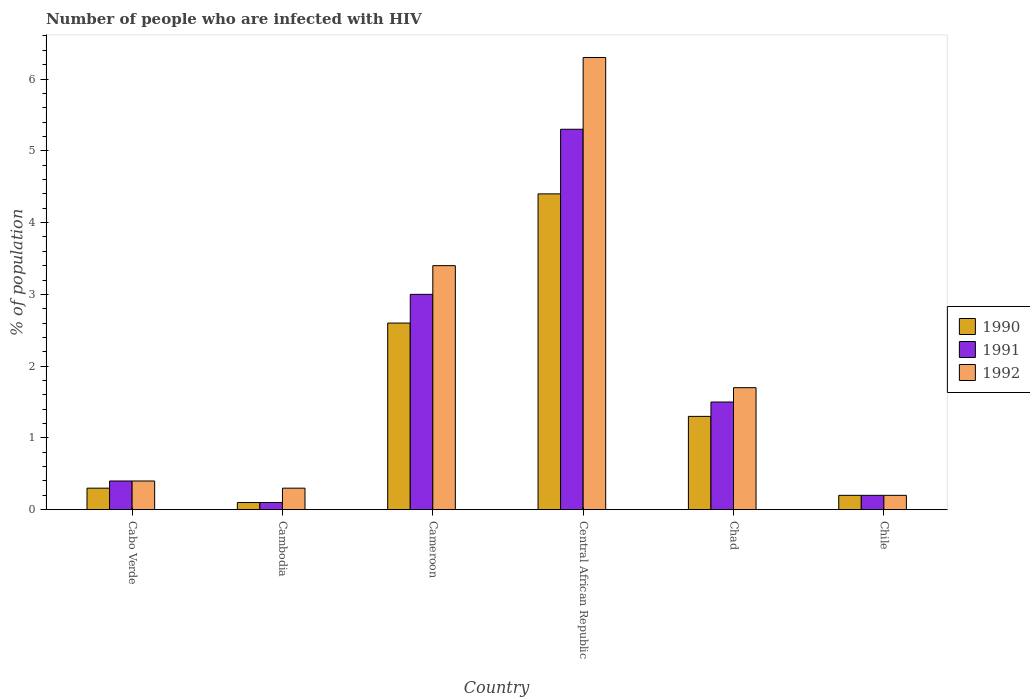How many groups of bars are there?
Provide a short and direct response. 6. Are the number of bars on each tick of the X-axis equal?
Your answer should be very brief. Yes. How many bars are there on the 3rd tick from the right?
Offer a very short reply. 3. What is the percentage of HIV infected population in in 1991 in Central African Republic?
Your response must be concise. 5.3. Across all countries, what is the maximum percentage of HIV infected population in in 1992?
Keep it short and to the point. 6.3. Across all countries, what is the minimum percentage of HIV infected population in in 1990?
Give a very brief answer. 0.1. In which country was the percentage of HIV infected population in in 1991 maximum?
Your response must be concise. Central African Republic. In which country was the percentage of HIV infected population in in 1990 minimum?
Give a very brief answer. Cambodia. What is the difference between the percentage of HIV infected population in in 1992 in Cameroon and that in Central African Republic?
Make the answer very short. -2.9. What is the difference between the percentage of HIV infected population in in 1991 in Cabo Verde and the percentage of HIV infected population in in 1992 in Chad?
Make the answer very short. -1.3. What is the difference between the percentage of HIV infected population in of/in 1991 and percentage of HIV infected population in of/in 1992 in Cambodia?
Give a very brief answer. -0.2. In how many countries, is the percentage of HIV infected population in in 1990 greater than 1.4 %?
Ensure brevity in your answer.  2. What is the ratio of the percentage of HIV infected population in in 1991 in Cambodia to that in Chad?
Ensure brevity in your answer.  0.07. Is the percentage of HIV infected population in in 1992 in Cameroon less than that in Central African Republic?
Make the answer very short. Yes. Is the difference between the percentage of HIV infected population in in 1991 in Central African Republic and Chile greater than the difference between the percentage of HIV infected population in in 1992 in Central African Republic and Chile?
Give a very brief answer. No. Is the sum of the percentage of HIV infected population in in 1990 in Central African Republic and Chad greater than the maximum percentage of HIV infected population in in 1992 across all countries?
Give a very brief answer. No. What does the 2nd bar from the left in Chad represents?
Your answer should be very brief. 1991. What does the 1st bar from the right in Chad represents?
Offer a very short reply. 1992. Is it the case that in every country, the sum of the percentage of HIV infected population in in 1990 and percentage of HIV infected population in in 1991 is greater than the percentage of HIV infected population in in 1992?
Your answer should be very brief. No. How many countries are there in the graph?
Your answer should be compact. 6. Does the graph contain any zero values?
Make the answer very short. No. Where does the legend appear in the graph?
Provide a succinct answer. Center right. How many legend labels are there?
Provide a short and direct response. 3. What is the title of the graph?
Ensure brevity in your answer.  Number of people who are infected with HIV. What is the label or title of the Y-axis?
Keep it short and to the point. % of population. What is the % of population of 1990 in Cabo Verde?
Offer a terse response. 0.3. What is the % of population of 1991 in Cabo Verde?
Your answer should be compact. 0.4. What is the % of population of 1992 in Cabo Verde?
Make the answer very short. 0.4. What is the % of population in 1992 in Cambodia?
Provide a short and direct response. 0.3. What is the % of population in 1990 in Cameroon?
Offer a terse response. 2.6. What is the % of population of 1991 in Cameroon?
Offer a very short reply. 3. What is the % of population of 1992 in Cameroon?
Give a very brief answer. 3.4. What is the % of population of 1991 in Central African Republic?
Your answer should be compact. 5.3. What is the % of population in 1992 in Central African Republic?
Offer a very short reply. 6.3. What is the % of population of 1991 in Chad?
Offer a terse response. 1.5. What is the % of population of 1992 in Chad?
Make the answer very short. 1.7. What is the % of population in 1992 in Chile?
Offer a terse response. 0.2. Across all countries, what is the maximum % of population in 1991?
Provide a short and direct response. 5.3. Across all countries, what is the minimum % of population of 1990?
Your response must be concise. 0.1. Across all countries, what is the minimum % of population of 1992?
Provide a short and direct response. 0.2. What is the total % of population of 1992 in the graph?
Your response must be concise. 12.3. What is the difference between the % of population of 1990 in Cabo Verde and that in Cambodia?
Keep it short and to the point. 0.2. What is the difference between the % of population of 1991 in Cabo Verde and that in Cambodia?
Provide a succinct answer. 0.3. What is the difference between the % of population in 1992 in Cabo Verde and that in Cambodia?
Your answer should be very brief. 0.1. What is the difference between the % of population of 1990 in Cabo Verde and that in Cameroon?
Give a very brief answer. -2.3. What is the difference between the % of population in 1991 in Cabo Verde and that in Cameroon?
Ensure brevity in your answer.  -2.6. What is the difference between the % of population in 1992 in Cabo Verde and that in Cameroon?
Your answer should be compact. -3. What is the difference between the % of population of 1990 in Cabo Verde and that in Central African Republic?
Keep it short and to the point. -4.1. What is the difference between the % of population of 1991 in Cabo Verde and that in Central African Republic?
Make the answer very short. -4.9. What is the difference between the % of population of 1990 in Cabo Verde and that in Chile?
Give a very brief answer. 0.1. What is the difference between the % of population in 1991 in Cambodia and that in Cameroon?
Your answer should be very brief. -2.9. What is the difference between the % of population of 1992 in Cambodia and that in Cameroon?
Make the answer very short. -3.1. What is the difference between the % of population in 1990 in Cambodia and that in Chad?
Your answer should be very brief. -1.2. What is the difference between the % of population in 1992 in Cambodia and that in Chad?
Keep it short and to the point. -1.4. What is the difference between the % of population in 1990 in Cambodia and that in Chile?
Offer a very short reply. -0.1. What is the difference between the % of population of 1992 in Cambodia and that in Chile?
Give a very brief answer. 0.1. What is the difference between the % of population of 1990 in Cameroon and that in Central African Republic?
Keep it short and to the point. -1.8. What is the difference between the % of population of 1992 in Cameroon and that in Central African Republic?
Your response must be concise. -2.9. What is the difference between the % of population of 1990 in Cameroon and that in Chad?
Provide a short and direct response. 1.3. What is the difference between the % of population of 1992 in Cameroon and that in Chad?
Keep it short and to the point. 1.7. What is the difference between the % of population of 1992 in Cameroon and that in Chile?
Offer a terse response. 3.2. What is the difference between the % of population in 1990 in Central African Republic and that in Chad?
Your answer should be very brief. 3.1. What is the difference between the % of population in 1991 in Central African Republic and that in Chad?
Offer a very short reply. 3.8. What is the difference between the % of population in 1990 in Central African Republic and that in Chile?
Ensure brevity in your answer.  4.2. What is the difference between the % of population in 1991 in Central African Republic and that in Chile?
Your response must be concise. 5.1. What is the difference between the % of population in 1990 in Chad and that in Chile?
Give a very brief answer. 1.1. What is the difference between the % of population in 1991 in Chad and that in Chile?
Give a very brief answer. 1.3. What is the difference between the % of population of 1990 in Cabo Verde and the % of population of 1992 in Cambodia?
Your response must be concise. 0. What is the difference between the % of population in 1991 in Cabo Verde and the % of population in 1992 in Cambodia?
Your response must be concise. 0.1. What is the difference between the % of population in 1990 in Cabo Verde and the % of population in 1991 in Cameroon?
Offer a terse response. -2.7. What is the difference between the % of population in 1990 in Cabo Verde and the % of population in 1992 in Cameroon?
Give a very brief answer. -3.1. What is the difference between the % of population in 1990 in Cabo Verde and the % of population in 1991 in Central African Republic?
Your answer should be very brief. -5. What is the difference between the % of population of 1990 in Cabo Verde and the % of population of 1992 in Central African Republic?
Make the answer very short. -6. What is the difference between the % of population of 1990 in Cabo Verde and the % of population of 1992 in Chile?
Make the answer very short. 0.1. What is the difference between the % of population of 1990 in Cambodia and the % of population of 1991 in Cameroon?
Provide a short and direct response. -2.9. What is the difference between the % of population of 1991 in Cambodia and the % of population of 1992 in Cameroon?
Give a very brief answer. -3.3. What is the difference between the % of population in 1991 in Cambodia and the % of population in 1992 in Central African Republic?
Keep it short and to the point. -6.2. What is the difference between the % of population in 1990 in Cambodia and the % of population in 1991 in Chad?
Offer a very short reply. -1.4. What is the difference between the % of population of 1990 in Cambodia and the % of population of 1991 in Chile?
Keep it short and to the point. -0.1. What is the difference between the % of population in 1990 in Cambodia and the % of population in 1992 in Chile?
Offer a terse response. -0.1. What is the difference between the % of population in 1990 in Cameroon and the % of population in 1991 in Central African Republic?
Offer a very short reply. -2.7. What is the difference between the % of population in 1990 in Cameroon and the % of population in 1992 in Central African Republic?
Keep it short and to the point. -3.7. What is the difference between the % of population in 1990 in Cameroon and the % of population in 1991 in Chad?
Your answer should be compact. 1.1. What is the difference between the % of population in 1990 in Cameroon and the % of population in 1991 in Chile?
Provide a succinct answer. 2.4. What is the difference between the % of population in 1990 in Cameroon and the % of population in 1992 in Chile?
Offer a terse response. 2.4. What is the difference between the % of population in 1991 in Central African Republic and the % of population in 1992 in Chad?
Give a very brief answer. 3.6. What is the difference between the % of population in 1990 in Central African Republic and the % of population in 1992 in Chile?
Make the answer very short. 4.2. What is the difference between the % of population in 1990 in Chad and the % of population in 1992 in Chile?
Ensure brevity in your answer.  1.1. What is the average % of population in 1990 per country?
Provide a short and direct response. 1.48. What is the average % of population in 1991 per country?
Offer a terse response. 1.75. What is the average % of population in 1992 per country?
Your answer should be compact. 2.05. What is the difference between the % of population of 1990 and % of population of 1991 in Cabo Verde?
Give a very brief answer. -0.1. What is the difference between the % of population in 1990 and % of population in 1992 in Cambodia?
Make the answer very short. -0.2. What is the difference between the % of population in 1991 and % of population in 1992 in Cambodia?
Give a very brief answer. -0.2. What is the difference between the % of population of 1990 and % of population of 1991 in Cameroon?
Offer a terse response. -0.4. What is the difference between the % of population of 1991 and % of population of 1992 in Cameroon?
Your answer should be very brief. -0.4. What is the difference between the % of population of 1990 and % of population of 1992 in Central African Republic?
Your answer should be very brief. -1.9. What is the difference between the % of population in 1990 and % of population in 1992 in Chad?
Your answer should be compact. -0.4. What is the difference between the % of population of 1990 and % of population of 1991 in Chile?
Provide a short and direct response. 0. What is the difference between the % of population of 1990 and % of population of 1992 in Chile?
Offer a very short reply. 0. What is the difference between the % of population of 1991 and % of population of 1992 in Chile?
Your response must be concise. 0. What is the ratio of the % of population of 1991 in Cabo Verde to that in Cambodia?
Keep it short and to the point. 4. What is the ratio of the % of population in 1992 in Cabo Verde to that in Cambodia?
Ensure brevity in your answer.  1.33. What is the ratio of the % of population in 1990 in Cabo Verde to that in Cameroon?
Your answer should be compact. 0.12. What is the ratio of the % of population of 1991 in Cabo Verde to that in Cameroon?
Ensure brevity in your answer.  0.13. What is the ratio of the % of population in 1992 in Cabo Verde to that in Cameroon?
Your answer should be very brief. 0.12. What is the ratio of the % of population in 1990 in Cabo Verde to that in Central African Republic?
Provide a short and direct response. 0.07. What is the ratio of the % of population in 1991 in Cabo Verde to that in Central African Republic?
Your answer should be very brief. 0.08. What is the ratio of the % of population in 1992 in Cabo Verde to that in Central African Republic?
Your answer should be very brief. 0.06. What is the ratio of the % of population of 1990 in Cabo Verde to that in Chad?
Ensure brevity in your answer.  0.23. What is the ratio of the % of population of 1991 in Cabo Verde to that in Chad?
Make the answer very short. 0.27. What is the ratio of the % of population in 1992 in Cabo Verde to that in Chad?
Your answer should be very brief. 0.24. What is the ratio of the % of population of 1990 in Cabo Verde to that in Chile?
Give a very brief answer. 1.5. What is the ratio of the % of population of 1991 in Cabo Verde to that in Chile?
Make the answer very short. 2. What is the ratio of the % of population in 1992 in Cabo Verde to that in Chile?
Your answer should be very brief. 2. What is the ratio of the % of population in 1990 in Cambodia to that in Cameroon?
Your answer should be very brief. 0.04. What is the ratio of the % of population in 1992 in Cambodia to that in Cameroon?
Give a very brief answer. 0.09. What is the ratio of the % of population in 1990 in Cambodia to that in Central African Republic?
Offer a terse response. 0.02. What is the ratio of the % of population in 1991 in Cambodia to that in Central African Republic?
Keep it short and to the point. 0.02. What is the ratio of the % of population of 1992 in Cambodia to that in Central African Republic?
Your answer should be very brief. 0.05. What is the ratio of the % of population of 1990 in Cambodia to that in Chad?
Make the answer very short. 0.08. What is the ratio of the % of population in 1991 in Cambodia to that in Chad?
Your answer should be very brief. 0.07. What is the ratio of the % of population of 1992 in Cambodia to that in Chad?
Offer a terse response. 0.18. What is the ratio of the % of population of 1990 in Cameroon to that in Central African Republic?
Ensure brevity in your answer.  0.59. What is the ratio of the % of population in 1991 in Cameroon to that in Central African Republic?
Make the answer very short. 0.57. What is the ratio of the % of population in 1992 in Cameroon to that in Central African Republic?
Your response must be concise. 0.54. What is the ratio of the % of population in 1990 in Cameroon to that in Chad?
Keep it short and to the point. 2. What is the ratio of the % of population of 1991 in Cameroon to that in Chad?
Offer a very short reply. 2. What is the ratio of the % of population of 1992 in Cameroon to that in Chad?
Give a very brief answer. 2. What is the ratio of the % of population in 1991 in Cameroon to that in Chile?
Your answer should be compact. 15. What is the ratio of the % of population of 1992 in Cameroon to that in Chile?
Your answer should be compact. 17. What is the ratio of the % of population in 1990 in Central African Republic to that in Chad?
Ensure brevity in your answer.  3.38. What is the ratio of the % of population in 1991 in Central African Republic to that in Chad?
Provide a succinct answer. 3.53. What is the ratio of the % of population in 1992 in Central African Republic to that in Chad?
Provide a succinct answer. 3.71. What is the ratio of the % of population of 1991 in Central African Republic to that in Chile?
Give a very brief answer. 26.5. What is the ratio of the % of population of 1992 in Central African Republic to that in Chile?
Give a very brief answer. 31.5. What is the ratio of the % of population of 1990 in Chad to that in Chile?
Keep it short and to the point. 6.5. What is the difference between the highest and the second highest % of population of 1990?
Your answer should be compact. 1.8. What is the difference between the highest and the second highest % of population in 1992?
Provide a succinct answer. 2.9. What is the difference between the highest and the lowest % of population of 1990?
Offer a terse response. 4.3. 